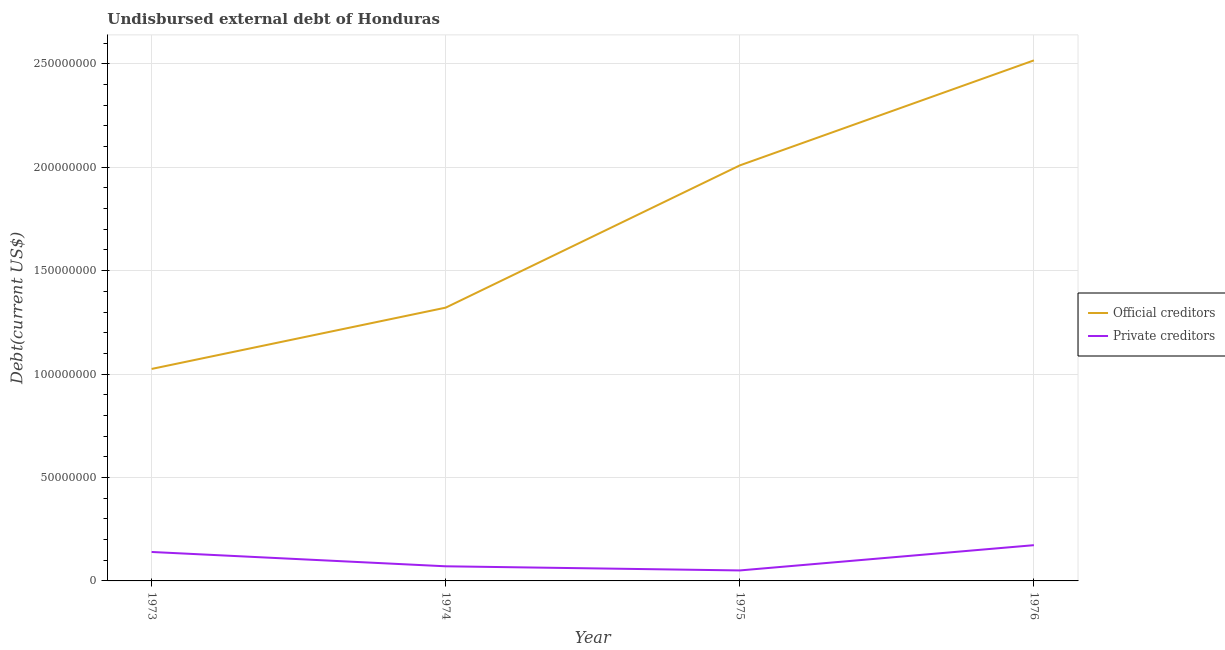How many different coloured lines are there?
Offer a very short reply. 2. Is the number of lines equal to the number of legend labels?
Ensure brevity in your answer.  Yes. What is the undisbursed external debt of private creditors in 1975?
Provide a short and direct response. 5.07e+06. Across all years, what is the maximum undisbursed external debt of official creditors?
Offer a very short reply. 2.52e+08. Across all years, what is the minimum undisbursed external debt of private creditors?
Give a very brief answer. 5.07e+06. In which year was the undisbursed external debt of official creditors maximum?
Make the answer very short. 1976. In which year was the undisbursed external debt of official creditors minimum?
Give a very brief answer. 1973. What is the total undisbursed external debt of private creditors in the graph?
Your answer should be very brief. 4.34e+07. What is the difference between the undisbursed external debt of official creditors in 1974 and that in 1975?
Provide a short and direct response. -6.88e+07. What is the difference between the undisbursed external debt of private creditors in 1974 and the undisbursed external debt of official creditors in 1976?
Your answer should be compact. -2.45e+08. What is the average undisbursed external debt of official creditors per year?
Make the answer very short. 1.72e+08. In the year 1976, what is the difference between the undisbursed external debt of private creditors and undisbursed external debt of official creditors?
Provide a succinct answer. -2.34e+08. What is the ratio of the undisbursed external debt of private creditors in 1973 to that in 1976?
Keep it short and to the point. 0.81. Is the undisbursed external debt of official creditors in 1973 less than that in 1976?
Provide a short and direct response. Yes. What is the difference between the highest and the second highest undisbursed external debt of official creditors?
Your answer should be very brief. 5.08e+07. What is the difference between the highest and the lowest undisbursed external debt of private creditors?
Keep it short and to the point. 1.22e+07. In how many years, is the undisbursed external debt of official creditors greater than the average undisbursed external debt of official creditors taken over all years?
Offer a very short reply. 2. Is the undisbursed external debt of official creditors strictly greater than the undisbursed external debt of private creditors over the years?
Your answer should be very brief. Yes. Is the undisbursed external debt of private creditors strictly less than the undisbursed external debt of official creditors over the years?
Provide a succinct answer. Yes. How many years are there in the graph?
Make the answer very short. 4. What is the difference between two consecutive major ticks on the Y-axis?
Give a very brief answer. 5.00e+07. Does the graph contain any zero values?
Keep it short and to the point. No. Does the graph contain grids?
Ensure brevity in your answer.  Yes. How are the legend labels stacked?
Give a very brief answer. Vertical. What is the title of the graph?
Offer a terse response. Undisbursed external debt of Honduras. What is the label or title of the Y-axis?
Provide a succinct answer. Debt(current US$). What is the Debt(current US$) in Official creditors in 1973?
Give a very brief answer. 1.02e+08. What is the Debt(current US$) of Private creditors in 1973?
Your response must be concise. 1.40e+07. What is the Debt(current US$) of Official creditors in 1974?
Keep it short and to the point. 1.32e+08. What is the Debt(current US$) in Private creditors in 1974?
Your answer should be compact. 7.07e+06. What is the Debt(current US$) in Official creditors in 1975?
Your response must be concise. 2.01e+08. What is the Debt(current US$) in Private creditors in 1975?
Your answer should be very brief. 5.07e+06. What is the Debt(current US$) of Official creditors in 1976?
Make the answer very short. 2.52e+08. What is the Debt(current US$) of Private creditors in 1976?
Your answer should be very brief. 1.73e+07. Across all years, what is the maximum Debt(current US$) in Official creditors?
Offer a very short reply. 2.52e+08. Across all years, what is the maximum Debt(current US$) of Private creditors?
Ensure brevity in your answer.  1.73e+07. Across all years, what is the minimum Debt(current US$) of Official creditors?
Make the answer very short. 1.02e+08. Across all years, what is the minimum Debt(current US$) in Private creditors?
Your answer should be very brief. 5.07e+06. What is the total Debt(current US$) in Official creditors in the graph?
Provide a succinct answer. 6.87e+08. What is the total Debt(current US$) in Private creditors in the graph?
Keep it short and to the point. 4.34e+07. What is the difference between the Debt(current US$) in Official creditors in 1973 and that in 1974?
Give a very brief answer. -2.96e+07. What is the difference between the Debt(current US$) of Private creditors in 1973 and that in 1974?
Ensure brevity in your answer.  6.93e+06. What is the difference between the Debt(current US$) in Official creditors in 1973 and that in 1975?
Your response must be concise. -9.84e+07. What is the difference between the Debt(current US$) in Private creditors in 1973 and that in 1975?
Your answer should be very brief. 8.93e+06. What is the difference between the Debt(current US$) in Official creditors in 1973 and that in 1976?
Give a very brief answer. -1.49e+08. What is the difference between the Debt(current US$) of Private creditors in 1973 and that in 1976?
Your response must be concise. -3.29e+06. What is the difference between the Debt(current US$) of Official creditors in 1974 and that in 1975?
Ensure brevity in your answer.  -6.88e+07. What is the difference between the Debt(current US$) of Private creditors in 1974 and that in 1975?
Make the answer very short. 2.00e+06. What is the difference between the Debt(current US$) in Official creditors in 1974 and that in 1976?
Offer a very short reply. -1.20e+08. What is the difference between the Debt(current US$) of Private creditors in 1974 and that in 1976?
Provide a short and direct response. -1.02e+07. What is the difference between the Debt(current US$) in Official creditors in 1975 and that in 1976?
Your answer should be compact. -5.08e+07. What is the difference between the Debt(current US$) of Private creditors in 1975 and that in 1976?
Offer a terse response. -1.22e+07. What is the difference between the Debt(current US$) in Official creditors in 1973 and the Debt(current US$) in Private creditors in 1974?
Your answer should be very brief. 9.54e+07. What is the difference between the Debt(current US$) of Official creditors in 1973 and the Debt(current US$) of Private creditors in 1975?
Make the answer very short. 9.74e+07. What is the difference between the Debt(current US$) of Official creditors in 1973 and the Debt(current US$) of Private creditors in 1976?
Provide a short and direct response. 8.52e+07. What is the difference between the Debt(current US$) of Official creditors in 1974 and the Debt(current US$) of Private creditors in 1975?
Your answer should be very brief. 1.27e+08. What is the difference between the Debt(current US$) of Official creditors in 1974 and the Debt(current US$) of Private creditors in 1976?
Give a very brief answer. 1.15e+08. What is the difference between the Debt(current US$) of Official creditors in 1975 and the Debt(current US$) of Private creditors in 1976?
Provide a succinct answer. 1.84e+08. What is the average Debt(current US$) in Official creditors per year?
Give a very brief answer. 1.72e+08. What is the average Debt(current US$) of Private creditors per year?
Make the answer very short. 1.09e+07. In the year 1973, what is the difference between the Debt(current US$) in Official creditors and Debt(current US$) in Private creditors?
Offer a very short reply. 8.85e+07. In the year 1974, what is the difference between the Debt(current US$) in Official creditors and Debt(current US$) in Private creditors?
Your answer should be very brief. 1.25e+08. In the year 1975, what is the difference between the Debt(current US$) of Official creditors and Debt(current US$) of Private creditors?
Provide a short and direct response. 1.96e+08. In the year 1976, what is the difference between the Debt(current US$) of Official creditors and Debt(current US$) of Private creditors?
Provide a succinct answer. 2.34e+08. What is the ratio of the Debt(current US$) of Official creditors in 1973 to that in 1974?
Give a very brief answer. 0.78. What is the ratio of the Debt(current US$) of Private creditors in 1973 to that in 1974?
Your response must be concise. 1.98. What is the ratio of the Debt(current US$) of Official creditors in 1973 to that in 1975?
Your answer should be very brief. 0.51. What is the ratio of the Debt(current US$) of Private creditors in 1973 to that in 1975?
Give a very brief answer. 2.76. What is the ratio of the Debt(current US$) of Official creditors in 1973 to that in 1976?
Ensure brevity in your answer.  0.41. What is the ratio of the Debt(current US$) in Private creditors in 1973 to that in 1976?
Make the answer very short. 0.81. What is the ratio of the Debt(current US$) of Official creditors in 1974 to that in 1975?
Your answer should be compact. 0.66. What is the ratio of the Debt(current US$) of Private creditors in 1974 to that in 1975?
Ensure brevity in your answer.  1.39. What is the ratio of the Debt(current US$) in Official creditors in 1974 to that in 1976?
Make the answer very short. 0.53. What is the ratio of the Debt(current US$) of Private creditors in 1974 to that in 1976?
Offer a very short reply. 0.41. What is the ratio of the Debt(current US$) in Official creditors in 1975 to that in 1976?
Give a very brief answer. 0.8. What is the ratio of the Debt(current US$) in Private creditors in 1975 to that in 1976?
Ensure brevity in your answer.  0.29. What is the difference between the highest and the second highest Debt(current US$) of Official creditors?
Offer a very short reply. 5.08e+07. What is the difference between the highest and the second highest Debt(current US$) of Private creditors?
Provide a short and direct response. 3.29e+06. What is the difference between the highest and the lowest Debt(current US$) of Official creditors?
Your answer should be compact. 1.49e+08. What is the difference between the highest and the lowest Debt(current US$) in Private creditors?
Give a very brief answer. 1.22e+07. 